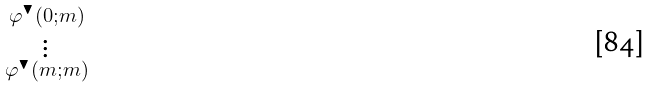<formula> <loc_0><loc_0><loc_500><loc_500>\begin{smallmatrix} \varphi ^ { \blacktriangledown } ( 0 ; m ) \\ \vdots \\ \varphi ^ { \blacktriangledown } ( m ; m ) \end{smallmatrix}</formula> 